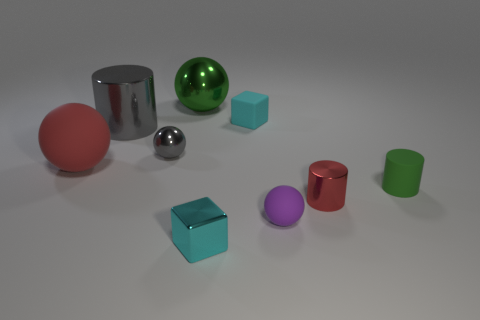Add 1 tiny green objects. How many objects exist? 10 Subtract all cylinders. How many objects are left? 6 Add 2 tiny red things. How many tiny red things exist? 3 Subtract 1 red spheres. How many objects are left? 8 Subtract all large green objects. Subtract all small gray objects. How many objects are left? 7 Add 1 tiny gray spheres. How many tiny gray spheres are left? 2 